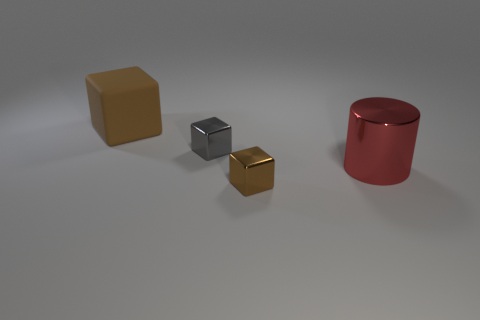What materials do these objects appear to be made of? The texture and sheen of the objects suggest that the large brown cube might be made of a matte material like wood, the gray shiny block looks metallic, the small gold cube appears to be a polished metal, and the red cylinder has a surface reflective quality indicative of a painted metal or plastic. 